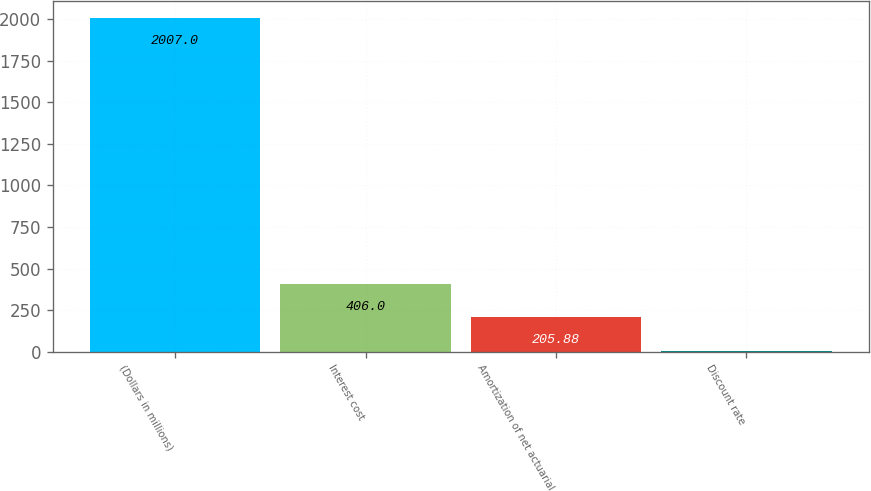<chart> <loc_0><loc_0><loc_500><loc_500><bar_chart><fcel>(Dollars in millions)<fcel>Interest cost<fcel>Amortization of net actuarial<fcel>Discount rate<nl><fcel>2007<fcel>406<fcel>205.88<fcel>5.75<nl></chart> 